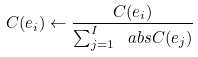Convert formula to latex. <formula><loc_0><loc_0><loc_500><loc_500>C ( e _ { i } ) \gets \frac { C ( e _ { i } ) } { \sum _ { j = 1 } ^ { I } \ a b s { C ( e _ { j } ) } }</formula> 